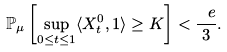Convert formula to latex. <formula><loc_0><loc_0><loc_500><loc_500>\mathbb { P } _ { \mu } \left [ \sup _ { 0 \leq t \leq 1 } \langle X _ { t } ^ { 0 } , 1 \rangle \geq K \right ] < \frac { \ e } { 3 } .</formula> 